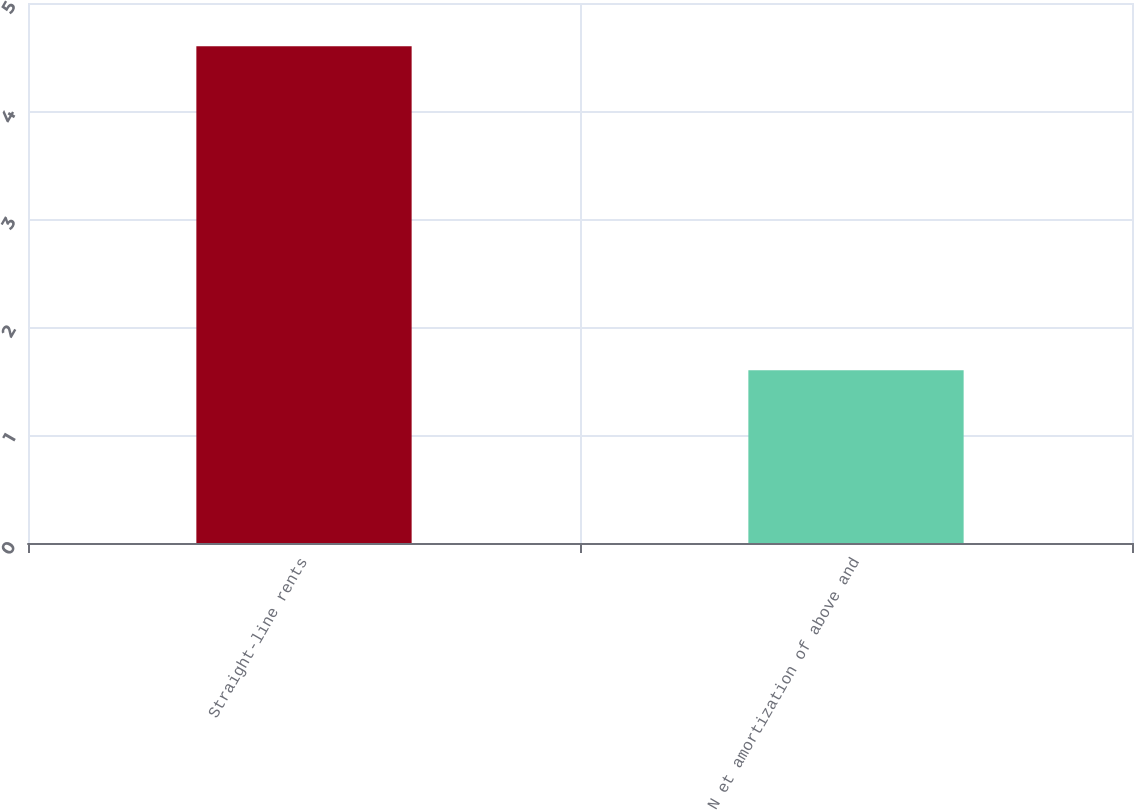<chart> <loc_0><loc_0><loc_500><loc_500><bar_chart><fcel>Straight-line rents<fcel>N et amortization of above and<nl><fcel>4.6<fcel>1.6<nl></chart> 